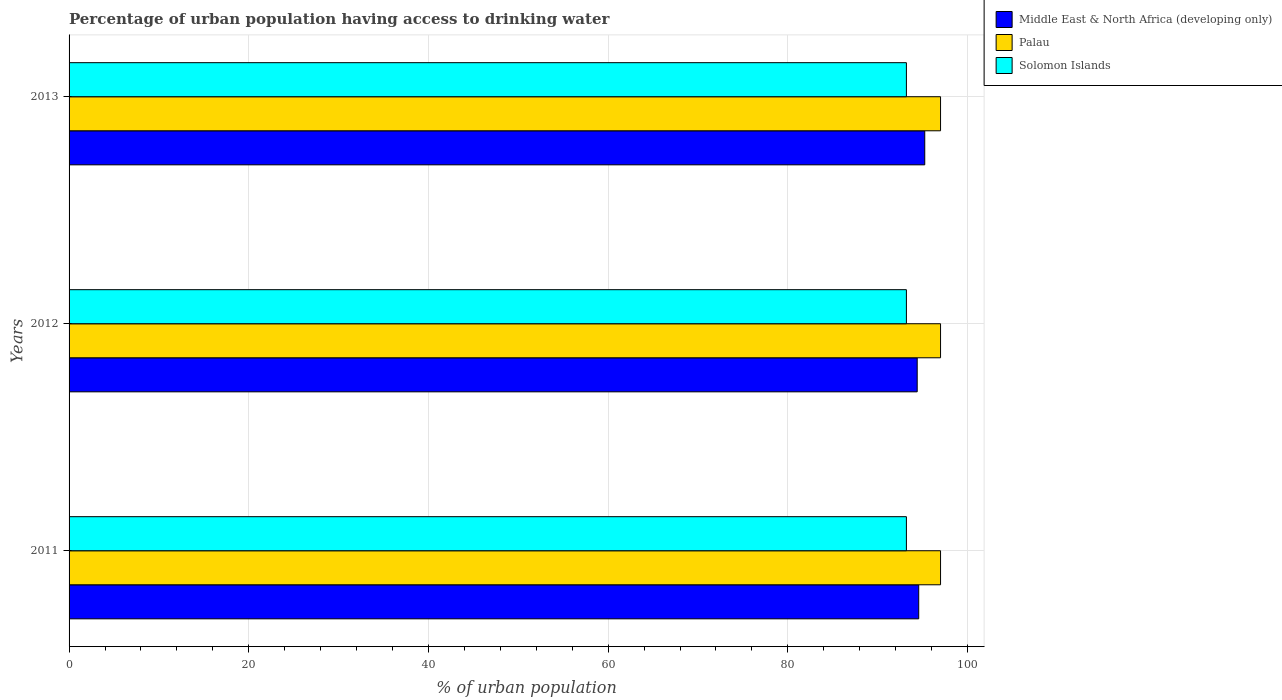How many different coloured bars are there?
Offer a very short reply. 3. Are the number of bars on each tick of the Y-axis equal?
Keep it short and to the point. Yes. What is the percentage of urban population having access to drinking water in Palau in 2012?
Your answer should be compact. 97. Across all years, what is the maximum percentage of urban population having access to drinking water in Solomon Islands?
Offer a very short reply. 93.2. Across all years, what is the minimum percentage of urban population having access to drinking water in Solomon Islands?
Ensure brevity in your answer.  93.2. In which year was the percentage of urban population having access to drinking water in Palau maximum?
Your answer should be very brief. 2011. In which year was the percentage of urban population having access to drinking water in Solomon Islands minimum?
Make the answer very short. 2011. What is the total percentage of urban population having access to drinking water in Solomon Islands in the graph?
Your answer should be compact. 279.6. What is the difference between the percentage of urban population having access to drinking water in Middle East & North Africa (developing only) in 2011 and that in 2013?
Your response must be concise. -0.67. What is the difference between the percentage of urban population having access to drinking water in Solomon Islands in 2013 and the percentage of urban population having access to drinking water in Palau in 2012?
Your answer should be very brief. -3.8. What is the average percentage of urban population having access to drinking water in Solomon Islands per year?
Offer a terse response. 93.2. In the year 2011, what is the difference between the percentage of urban population having access to drinking water in Solomon Islands and percentage of urban population having access to drinking water in Palau?
Your response must be concise. -3.8. In how many years, is the percentage of urban population having access to drinking water in Middle East & North Africa (developing only) greater than 24 %?
Provide a short and direct response. 3. What is the ratio of the percentage of urban population having access to drinking water in Middle East & North Africa (developing only) in 2012 to that in 2013?
Give a very brief answer. 0.99. Is the difference between the percentage of urban population having access to drinking water in Solomon Islands in 2012 and 2013 greater than the difference between the percentage of urban population having access to drinking water in Palau in 2012 and 2013?
Provide a short and direct response. No. What is the difference between the highest and the second highest percentage of urban population having access to drinking water in Palau?
Your answer should be compact. 0. What is the difference between the highest and the lowest percentage of urban population having access to drinking water in Middle East & North Africa (developing only)?
Ensure brevity in your answer.  0.84. In how many years, is the percentage of urban population having access to drinking water in Middle East & North Africa (developing only) greater than the average percentage of urban population having access to drinking water in Middle East & North Africa (developing only) taken over all years?
Give a very brief answer. 1. What does the 3rd bar from the top in 2011 represents?
Your answer should be very brief. Middle East & North Africa (developing only). What does the 2nd bar from the bottom in 2013 represents?
Provide a short and direct response. Palau. How many bars are there?
Keep it short and to the point. 9. How many years are there in the graph?
Offer a terse response. 3. What is the difference between two consecutive major ticks on the X-axis?
Offer a very short reply. 20. Are the values on the major ticks of X-axis written in scientific E-notation?
Offer a very short reply. No. Does the graph contain grids?
Your response must be concise. Yes. Where does the legend appear in the graph?
Your answer should be very brief. Top right. How many legend labels are there?
Provide a short and direct response. 3. What is the title of the graph?
Provide a short and direct response. Percentage of urban population having access to drinking water. What is the label or title of the X-axis?
Your answer should be very brief. % of urban population. What is the label or title of the Y-axis?
Make the answer very short. Years. What is the % of urban population of Middle East & North Africa (developing only) in 2011?
Provide a succinct answer. 94.57. What is the % of urban population in Palau in 2011?
Make the answer very short. 97. What is the % of urban population in Solomon Islands in 2011?
Provide a succinct answer. 93.2. What is the % of urban population in Middle East & North Africa (developing only) in 2012?
Provide a short and direct response. 94.4. What is the % of urban population of Palau in 2012?
Keep it short and to the point. 97. What is the % of urban population of Solomon Islands in 2012?
Your answer should be compact. 93.2. What is the % of urban population of Middle East & North Africa (developing only) in 2013?
Offer a very short reply. 95.24. What is the % of urban population in Palau in 2013?
Make the answer very short. 97. What is the % of urban population of Solomon Islands in 2013?
Your answer should be compact. 93.2. Across all years, what is the maximum % of urban population of Middle East & North Africa (developing only)?
Ensure brevity in your answer.  95.24. Across all years, what is the maximum % of urban population of Palau?
Make the answer very short. 97. Across all years, what is the maximum % of urban population in Solomon Islands?
Make the answer very short. 93.2. Across all years, what is the minimum % of urban population in Middle East & North Africa (developing only)?
Provide a succinct answer. 94.4. Across all years, what is the minimum % of urban population in Palau?
Provide a succinct answer. 97. Across all years, what is the minimum % of urban population of Solomon Islands?
Your response must be concise. 93.2. What is the total % of urban population in Middle East & North Africa (developing only) in the graph?
Make the answer very short. 284.21. What is the total % of urban population in Palau in the graph?
Your answer should be very brief. 291. What is the total % of urban population of Solomon Islands in the graph?
Your response must be concise. 279.6. What is the difference between the % of urban population of Middle East & North Africa (developing only) in 2011 and that in 2012?
Provide a short and direct response. 0.17. What is the difference between the % of urban population in Palau in 2011 and that in 2012?
Keep it short and to the point. 0. What is the difference between the % of urban population in Solomon Islands in 2011 and that in 2012?
Keep it short and to the point. 0. What is the difference between the % of urban population of Middle East & North Africa (developing only) in 2011 and that in 2013?
Your answer should be compact. -0.67. What is the difference between the % of urban population in Solomon Islands in 2011 and that in 2013?
Your answer should be compact. 0. What is the difference between the % of urban population of Middle East & North Africa (developing only) in 2012 and that in 2013?
Offer a very short reply. -0.84. What is the difference between the % of urban population of Palau in 2012 and that in 2013?
Give a very brief answer. 0. What is the difference between the % of urban population of Solomon Islands in 2012 and that in 2013?
Your answer should be compact. 0. What is the difference between the % of urban population of Middle East & North Africa (developing only) in 2011 and the % of urban population of Palau in 2012?
Make the answer very short. -2.43. What is the difference between the % of urban population of Middle East & North Africa (developing only) in 2011 and the % of urban population of Solomon Islands in 2012?
Provide a succinct answer. 1.37. What is the difference between the % of urban population in Palau in 2011 and the % of urban population in Solomon Islands in 2012?
Ensure brevity in your answer.  3.8. What is the difference between the % of urban population of Middle East & North Africa (developing only) in 2011 and the % of urban population of Palau in 2013?
Provide a short and direct response. -2.43. What is the difference between the % of urban population in Middle East & North Africa (developing only) in 2011 and the % of urban population in Solomon Islands in 2013?
Provide a succinct answer. 1.37. What is the difference between the % of urban population in Middle East & North Africa (developing only) in 2012 and the % of urban population in Palau in 2013?
Make the answer very short. -2.6. What is the difference between the % of urban population of Middle East & North Africa (developing only) in 2012 and the % of urban population of Solomon Islands in 2013?
Ensure brevity in your answer.  1.2. What is the difference between the % of urban population in Palau in 2012 and the % of urban population in Solomon Islands in 2013?
Offer a terse response. 3.8. What is the average % of urban population of Middle East & North Africa (developing only) per year?
Your answer should be compact. 94.74. What is the average % of urban population of Palau per year?
Offer a very short reply. 97. What is the average % of urban population in Solomon Islands per year?
Your answer should be very brief. 93.2. In the year 2011, what is the difference between the % of urban population in Middle East & North Africa (developing only) and % of urban population in Palau?
Your answer should be compact. -2.43. In the year 2011, what is the difference between the % of urban population of Middle East & North Africa (developing only) and % of urban population of Solomon Islands?
Offer a terse response. 1.37. In the year 2011, what is the difference between the % of urban population in Palau and % of urban population in Solomon Islands?
Give a very brief answer. 3.8. In the year 2012, what is the difference between the % of urban population of Middle East & North Africa (developing only) and % of urban population of Palau?
Your answer should be compact. -2.6. In the year 2012, what is the difference between the % of urban population of Middle East & North Africa (developing only) and % of urban population of Solomon Islands?
Make the answer very short. 1.2. In the year 2012, what is the difference between the % of urban population of Palau and % of urban population of Solomon Islands?
Your answer should be very brief. 3.8. In the year 2013, what is the difference between the % of urban population in Middle East & North Africa (developing only) and % of urban population in Palau?
Keep it short and to the point. -1.76. In the year 2013, what is the difference between the % of urban population in Middle East & North Africa (developing only) and % of urban population in Solomon Islands?
Offer a very short reply. 2.04. In the year 2013, what is the difference between the % of urban population of Palau and % of urban population of Solomon Islands?
Provide a succinct answer. 3.8. What is the ratio of the % of urban population of Middle East & North Africa (developing only) in 2011 to that in 2012?
Your answer should be compact. 1. What is the ratio of the % of urban population of Palau in 2011 to that in 2012?
Your answer should be very brief. 1. What is the ratio of the % of urban population of Middle East & North Africa (developing only) in 2011 to that in 2013?
Your answer should be compact. 0.99. What is the ratio of the % of urban population in Palau in 2011 to that in 2013?
Your response must be concise. 1. What is the ratio of the % of urban population of Solomon Islands in 2011 to that in 2013?
Provide a succinct answer. 1. What is the ratio of the % of urban population in Solomon Islands in 2012 to that in 2013?
Provide a succinct answer. 1. What is the difference between the highest and the second highest % of urban population of Middle East & North Africa (developing only)?
Keep it short and to the point. 0.67. What is the difference between the highest and the lowest % of urban population of Middle East & North Africa (developing only)?
Provide a succinct answer. 0.84. What is the difference between the highest and the lowest % of urban population in Palau?
Provide a short and direct response. 0. What is the difference between the highest and the lowest % of urban population in Solomon Islands?
Provide a succinct answer. 0. 